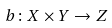Convert formula to latex. <formula><loc_0><loc_0><loc_500><loc_500>b \colon X \times Y \to Z</formula> 